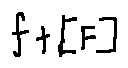<formula> <loc_0><loc_0><loc_500><loc_500>f + [ F ]</formula> 